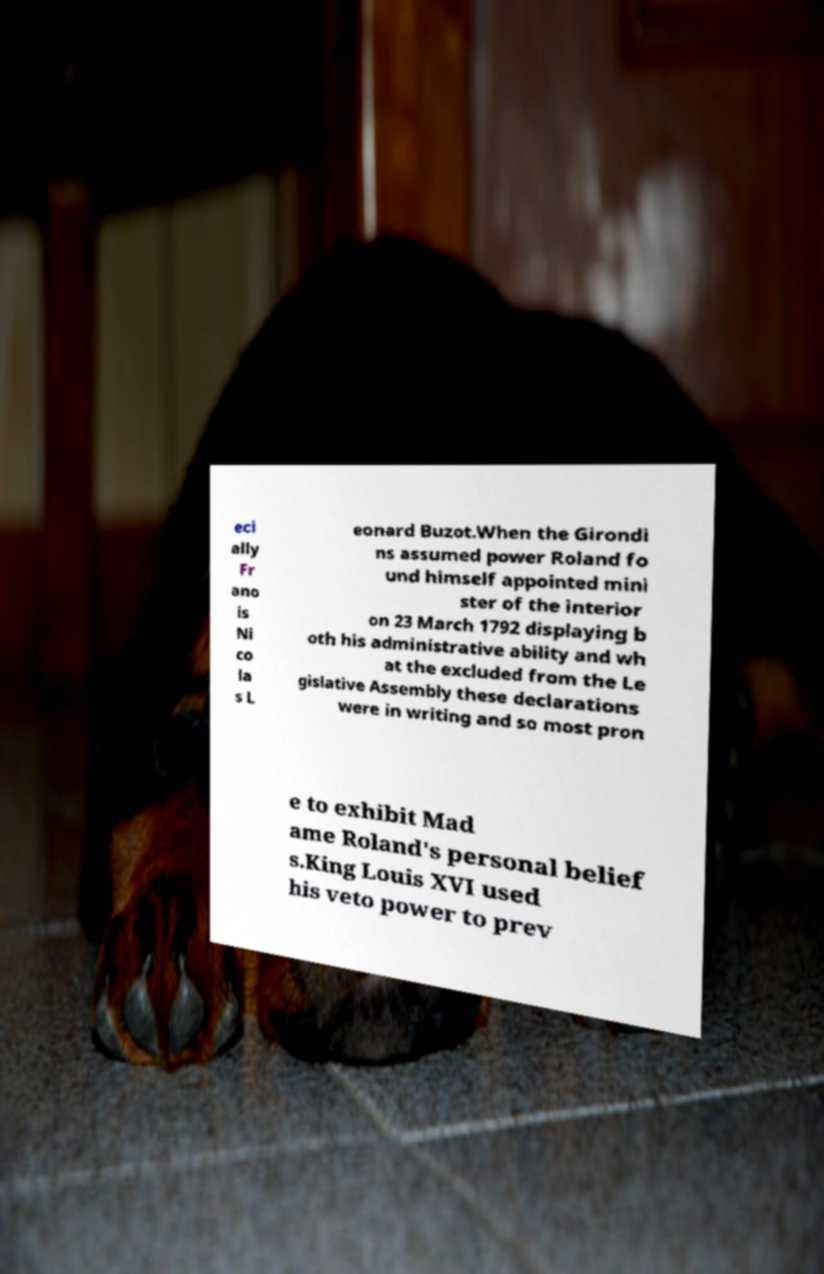I need the written content from this picture converted into text. Can you do that? eci ally Fr ano is Ni co la s L eonard Buzot.When the Girondi ns assumed power Roland fo und himself appointed mini ster of the interior on 23 March 1792 displaying b oth his administrative ability and wh at the excluded from the Le gislative Assembly these declarations were in writing and so most pron e to exhibit Mad ame Roland's personal belief s.King Louis XVI used his veto power to prev 